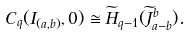Convert formula to latex. <formula><loc_0><loc_0><loc_500><loc_500>C _ { q } ( I _ { ( a , b ) } , 0 ) \cong \widetilde { H } _ { q - 1 } ( \widetilde { J } _ { a - b } ^ { b } ) .</formula> 